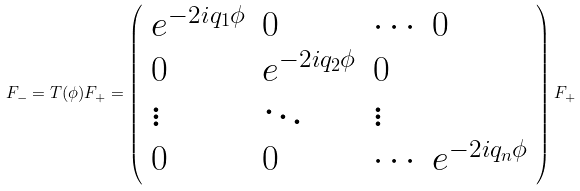Convert formula to latex. <formula><loc_0><loc_0><loc_500><loc_500>F _ { - } = T ( \phi ) F _ { + } = \left ( \begin{array} { l l l l } { { e ^ { - 2 i q _ { 1 } \phi } } } & { 0 } & { \cdots } & { 0 } \\ { 0 } & { { e ^ { - 2 i q _ { 2 } \phi } } } & { 0 } \\ { \vdots } & { \ddots } & { \vdots } \\ { 0 } & { 0 } & { \cdots } & { { e ^ { - 2 i q _ { n } \phi } } } \end{array} \right ) F _ { + }</formula> 